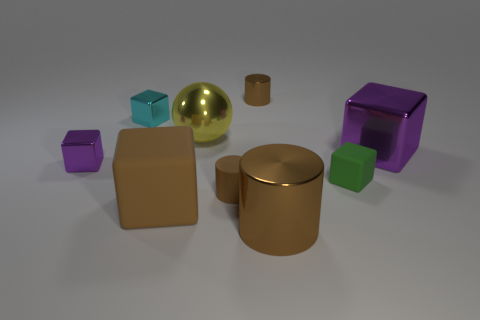Does the tiny metallic object in front of the yellow sphere have the same color as the large cube right of the tiny matte cylinder?
Your response must be concise. Yes. How many other objects are there of the same size as the green rubber object?
Give a very brief answer. 4. What is the color of the cube behind the yellow object?
Offer a very short reply. Cyan. What is the color of the big metallic thing that is the same shape as the large brown matte object?
Your response must be concise. Purple. Is there any other thing that has the same color as the matte cylinder?
Keep it short and to the point. Yes. Are there more matte blocks than cubes?
Keep it short and to the point. No. Do the cyan object and the big brown block have the same material?
Your answer should be compact. No. How many big purple cubes are the same material as the large brown cube?
Ensure brevity in your answer.  0. There is a yellow metallic sphere; is it the same size as the metallic cube on the right side of the large brown cylinder?
Ensure brevity in your answer.  Yes. What color is the metal cube that is in front of the tiny cyan cube and on the left side of the big purple metallic cube?
Make the answer very short. Purple. 